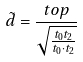<formula> <loc_0><loc_0><loc_500><loc_500>\tilde { d } = \frac { t o p } { \sqrt { \frac { t _ { 0 } t _ { 2 } } { t _ { 0 } \cdot t _ { 2 } } } }</formula> 